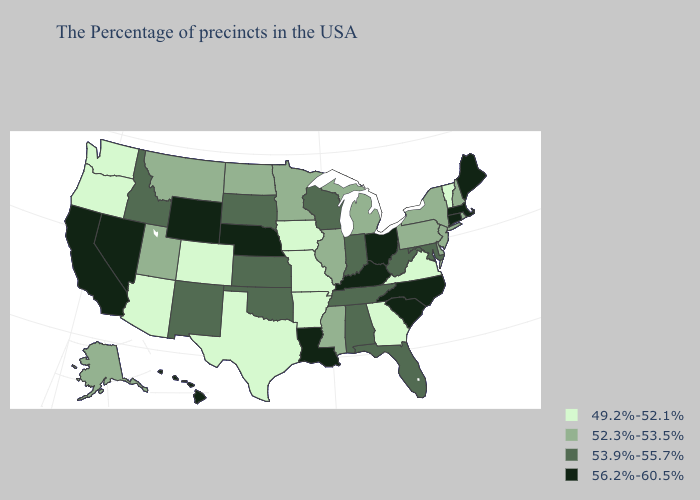Among the states that border West Virginia , which have the lowest value?
Answer briefly. Virginia. Name the states that have a value in the range 56.2%-60.5%?
Give a very brief answer. Maine, Massachusetts, Connecticut, North Carolina, South Carolina, Ohio, Kentucky, Louisiana, Nebraska, Wyoming, Nevada, California, Hawaii. Among the states that border New Mexico , does Utah have the lowest value?
Quick response, please. No. What is the lowest value in states that border Georgia?
Write a very short answer. 53.9%-55.7%. What is the value of Delaware?
Quick response, please. 52.3%-53.5%. What is the highest value in the USA?
Concise answer only. 56.2%-60.5%. What is the highest value in the USA?
Short answer required. 56.2%-60.5%. Which states hav the highest value in the MidWest?
Write a very short answer. Ohio, Nebraska. Does Michigan have the lowest value in the USA?
Concise answer only. No. Among the states that border North Carolina , which have the lowest value?
Quick response, please. Virginia, Georgia. What is the lowest value in the MidWest?
Be succinct. 49.2%-52.1%. What is the lowest value in states that border South Dakota?
Answer briefly. 49.2%-52.1%. What is the highest value in the West ?
Answer briefly. 56.2%-60.5%. Does Wyoming have the lowest value in the USA?
Be succinct. No. What is the value of Arkansas?
Answer briefly. 49.2%-52.1%. 